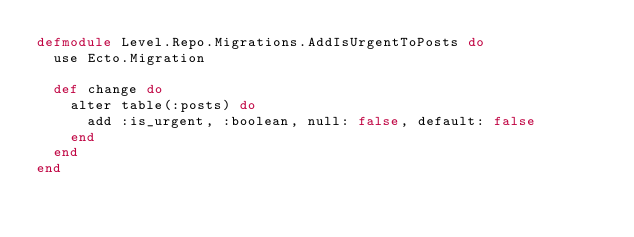Convert code to text. <code><loc_0><loc_0><loc_500><loc_500><_Elixir_>defmodule Level.Repo.Migrations.AddIsUrgentToPosts do
  use Ecto.Migration

  def change do
    alter table(:posts) do
      add :is_urgent, :boolean, null: false, default: false
    end
  end
end
</code> 